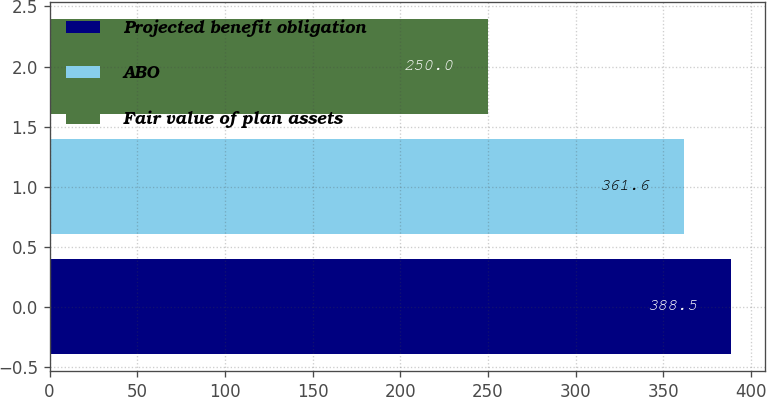<chart> <loc_0><loc_0><loc_500><loc_500><bar_chart><fcel>Projected benefit obligation<fcel>ABO<fcel>Fair value of plan assets<nl><fcel>388.5<fcel>361.6<fcel>250<nl></chart> 